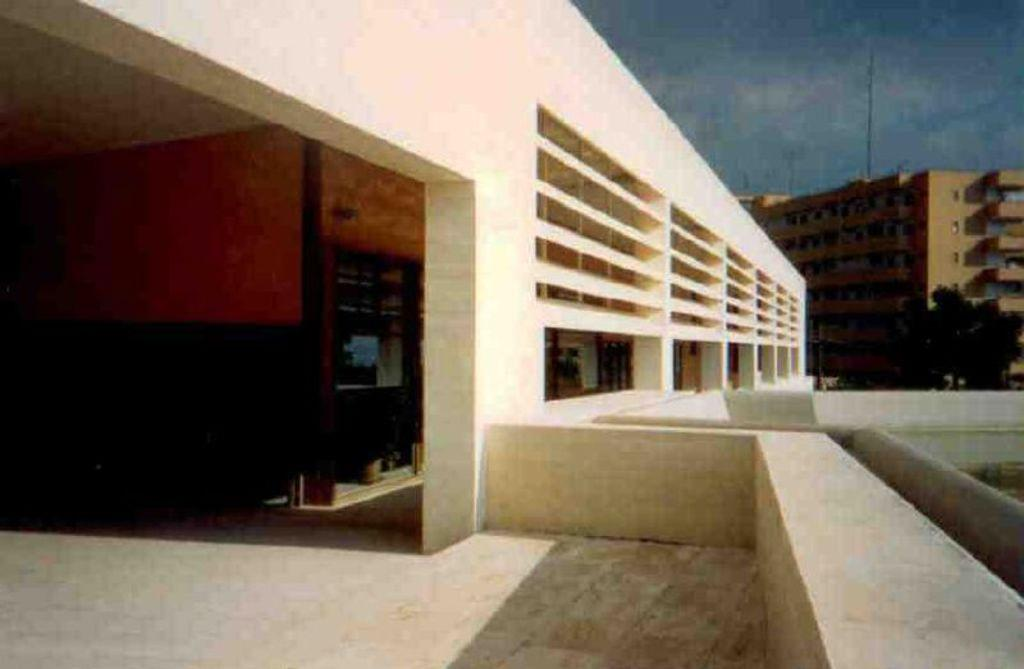What type of structures are present in the image? There are buildings with windows in the image. What else can be seen in the image besides the buildings? There are poles and trees in the image. What is visible in the background of the image? The sky is visible in the image. How would you describe the sky in the image? The sky appears to be cloudy in the image. What type of drug is being administered to the trees in the image? There is no drug being administered to the trees in the image; the trees are simply present in the image. 